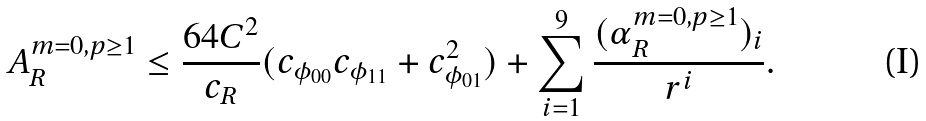<formula> <loc_0><loc_0><loc_500><loc_500>A _ { R } ^ { m = 0 , p \geq 1 } \leq \frac { 6 4 C ^ { 2 } } { c _ { R } } ( c _ { \phi _ { 0 0 } } c _ { \phi _ { 1 1 } } + c _ { \phi _ { 0 1 } } ^ { 2 } ) + \sum _ { i = 1 } ^ { 9 } \frac { ( \alpha _ { R } ^ { m = 0 , p \geq 1 } ) _ { i } } { r ^ { i } } .</formula> 